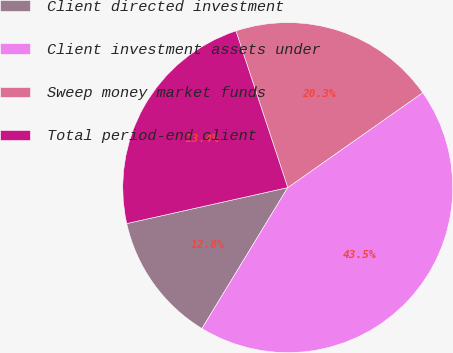<chart> <loc_0><loc_0><loc_500><loc_500><pie_chart><fcel>Client directed investment<fcel>Client investment assets under<fcel>Sweep money market funds<fcel>Total period-end client<nl><fcel>12.8%<fcel>43.46%<fcel>20.34%<fcel>23.41%<nl></chart> 